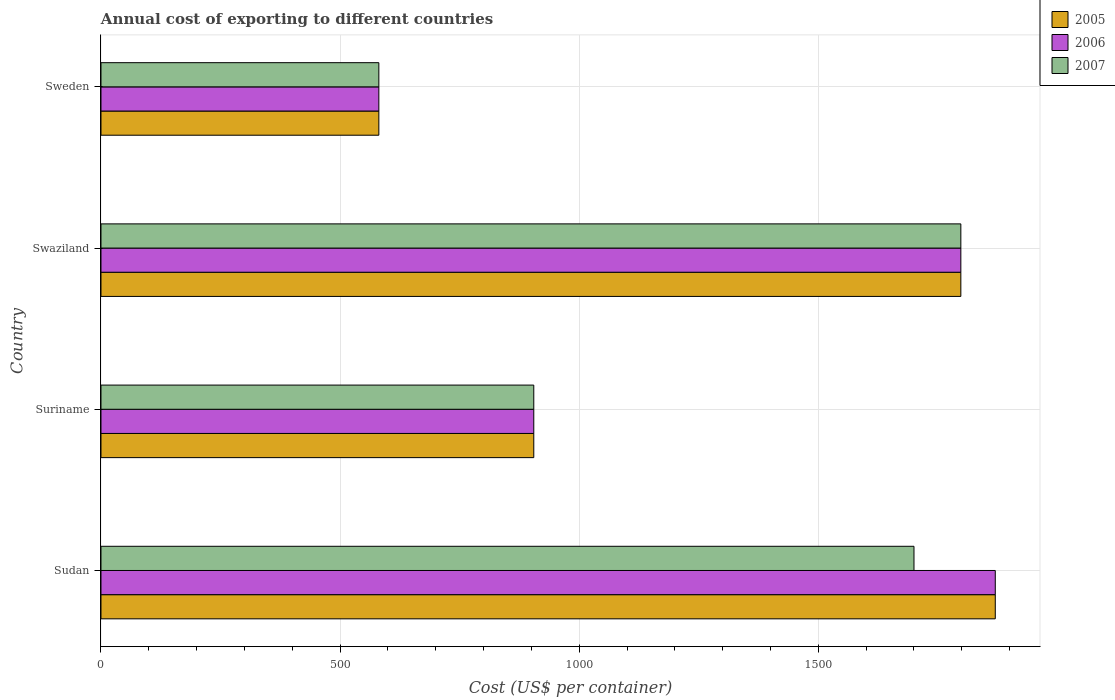How many different coloured bars are there?
Your answer should be very brief. 3. How many groups of bars are there?
Keep it short and to the point. 4. Are the number of bars per tick equal to the number of legend labels?
Give a very brief answer. Yes. How many bars are there on the 2nd tick from the top?
Make the answer very short. 3. How many bars are there on the 2nd tick from the bottom?
Make the answer very short. 3. What is the label of the 3rd group of bars from the top?
Provide a short and direct response. Suriname. What is the total annual cost of exporting in 2005 in Suriname?
Give a very brief answer. 905. Across all countries, what is the maximum total annual cost of exporting in 2007?
Provide a short and direct response. 1798. Across all countries, what is the minimum total annual cost of exporting in 2007?
Your response must be concise. 581. In which country was the total annual cost of exporting in 2007 maximum?
Provide a short and direct response. Swaziland. What is the total total annual cost of exporting in 2007 in the graph?
Provide a succinct answer. 4984. What is the difference between the total annual cost of exporting in 2007 in Sudan and that in Swaziland?
Offer a very short reply. -98. What is the difference between the total annual cost of exporting in 2007 in Suriname and the total annual cost of exporting in 2005 in Sweden?
Keep it short and to the point. 324. What is the average total annual cost of exporting in 2007 per country?
Provide a succinct answer. 1246. What is the difference between the total annual cost of exporting in 2005 and total annual cost of exporting in 2006 in Sudan?
Your answer should be very brief. 0. What is the ratio of the total annual cost of exporting in 2005 in Sudan to that in Suriname?
Give a very brief answer. 2.07. What is the difference between the highest and the lowest total annual cost of exporting in 2007?
Offer a very short reply. 1217. Is the sum of the total annual cost of exporting in 2006 in Suriname and Sweden greater than the maximum total annual cost of exporting in 2007 across all countries?
Ensure brevity in your answer.  No. What does the 2nd bar from the top in Sweden represents?
Provide a short and direct response. 2006. What does the 2nd bar from the bottom in Sudan represents?
Offer a very short reply. 2006. Is it the case that in every country, the sum of the total annual cost of exporting in 2006 and total annual cost of exporting in 2007 is greater than the total annual cost of exporting in 2005?
Your response must be concise. Yes. How many bars are there?
Your answer should be very brief. 12. What is the difference between two consecutive major ticks on the X-axis?
Keep it short and to the point. 500. Are the values on the major ticks of X-axis written in scientific E-notation?
Ensure brevity in your answer.  No. Does the graph contain any zero values?
Your answer should be compact. No. Does the graph contain grids?
Your answer should be compact. Yes. What is the title of the graph?
Provide a succinct answer. Annual cost of exporting to different countries. Does "1996" appear as one of the legend labels in the graph?
Provide a succinct answer. No. What is the label or title of the X-axis?
Your answer should be very brief. Cost (US$ per container). What is the Cost (US$ per container) of 2005 in Sudan?
Your response must be concise. 1870. What is the Cost (US$ per container) in 2006 in Sudan?
Provide a short and direct response. 1870. What is the Cost (US$ per container) of 2007 in Sudan?
Give a very brief answer. 1700. What is the Cost (US$ per container) in 2005 in Suriname?
Your answer should be compact. 905. What is the Cost (US$ per container) of 2006 in Suriname?
Keep it short and to the point. 905. What is the Cost (US$ per container) in 2007 in Suriname?
Your answer should be very brief. 905. What is the Cost (US$ per container) in 2005 in Swaziland?
Provide a succinct answer. 1798. What is the Cost (US$ per container) in 2006 in Swaziland?
Ensure brevity in your answer.  1798. What is the Cost (US$ per container) in 2007 in Swaziland?
Offer a very short reply. 1798. What is the Cost (US$ per container) of 2005 in Sweden?
Your response must be concise. 581. What is the Cost (US$ per container) in 2006 in Sweden?
Your response must be concise. 581. What is the Cost (US$ per container) of 2007 in Sweden?
Make the answer very short. 581. Across all countries, what is the maximum Cost (US$ per container) in 2005?
Your answer should be very brief. 1870. Across all countries, what is the maximum Cost (US$ per container) in 2006?
Provide a short and direct response. 1870. Across all countries, what is the maximum Cost (US$ per container) of 2007?
Offer a very short reply. 1798. Across all countries, what is the minimum Cost (US$ per container) in 2005?
Your answer should be very brief. 581. Across all countries, what is the minimum Cost (US$ per container) of 2006?
Your response must be concise. 581. Across all countries, what is the minimum Cost (US$ per container) in 2007?
Give a very brief answer. 581. What is the total Cost (US$ per container) in 2005 in the graph?
Your response must be concise. 5154. What is the total Cost (US$ per container) of 2006 in the graph?
Give a very brief answer. 5154. What is the total Cost (US$ per container) in 2007 in the graph?
Give a very brief answer. 4984. What is the difference between the Cost (US$ per container) of 2005 in Sudan and that in Suriname?
Give a very brief answer. 965. What is the difference between the Cost (US$ per container) in 2006 in Sudan and that in Suriname?
Your response must be concise. 965. What is the difference between the Cost (US$ per container) in 2007 in Sudan and that in Suriname?
Offer a terse response. 795. What is the difference between the Cost (US$ per container) in 2005 in Sudan and that in Swaziland?
Make the answer very short. 72. What is the difference between the Cost (US$ per container) in 2006 in Sudan and that in Swaziland?
Keep it short and to the point. 72. What is the difference between the Cost (US$ per container) in 2007 in Sudan and that in Swaziland?
Your answer should be very brief. -98. What is the difference between the Cost (US$ per container) of 2005 in Sudan and that in Sweden?
Give a very brief answer. 1289. What is the difference between the Cost (US$ per container) of 2006 in Sudan and that in Sweden?
Your answer should be very brief. 1289. What is the difference between the Cost (US$ per container) in 2007 in Sudan and that in Sweden?
Provide a short and direct response. 1119. What is the difference between the Cost (US$ per container) in 2005 in Suriname and that in Swaziland?
Make the answer very short. -893. What is the difference between the Cost (US$ per container) in 2006 in Suriname and that in Swaziland?
Keep it short and to the point. -893. What is the difference between the Cost (US$ per container) of 2007 in Suriname and that in Swaziland?
Offer a terse response. -893. What is the difference between the Cost (US$ per container) in 2005 in Suriname and that in Sweden?
Offer a very short reply. 324. What is the difference between the Cost (US$ per container) of 2006 in Suriname and that in Sweden?
Your response must be concise. 324. What is the difference between the Cost (US$ per container) in 2007 in Suriname and that in Sweden?
Provide a short and direct response. 324. What is the difference between the Cost (US$ per container) in 2005 in Swaziland and that in Sweden?
Your answer should be very brief. 1217. What is the difference between the Cost (US$ per container) of 2006 in Swaziland and that in Sweden?
Keep it short and to the point. 1217. What is the difference between the Cost (US$ per container) of 2007 in Swaziland and that in Sweden?
Keep it short and to the point. 1217. What is the difference between the Cost (US$ per container) of 2005 in Sudan and the Cost (US$ per container) of 2006 in Suriname?
Ensure brevity in your answer.  965. What is the difference between the Cost (US$ per container) of 2005 in Sudan and the Cost (US$ per container) of 2007 in Suriname?
Your response must be concise. 965. What is the difference between the Cost (US$ per container) in 2006 in Sudan and the Cost (US$ per container) in 2007 in Suriname?
Offer a terse response. 965. What is the difference between the Cost (US$ per container) of 2005 in Sudan and the Cost (US$ per container) of 2007 in Swaziland?
Keep it short and to the point. 72. What is the difference between the Cost (US$ per container) of 2005 in Sudan and the Cost (US$ per container) of 2006 in Sweden?
Provide a short and direct response. 1289. What is the difference between the Cost (US$ per container) in 2005 in Sudan and the Cost (US$ per container) in 2007 in Sweden?
Keep it short and to the point. 1289. What is the difference between the Cost (US$ per container) of 2006 in Sudan and the Cost (US$ per container) of 2007 in Sweden?
Make the answer very short. 1289. What is the difference between the Cost (US$ per container) of 2005 in Suriname and the Cost (US$ per container) of 2006 in Swaziland?
Make the answer very short. -893. What is the difference between the Cost (US$ per container) of 2005 in Suriname and the Cost (US$ per container) of 2007 in Swaziland?
Offer a very short reply. -893. What is the difference between the Cost (US$ per container) in 2006 in Suriname and the Cost (US$ per container) in 2007 in Swaziland?
Your response must be concise. -893. What is the difference between the Cost (US$ per container) in 2005 in Suriname and the Cost (US$ per container) in 2006 in Sweden?
Your answer should be very brief. 324. What is the difference between the Cost (US$ per container) in 2005 in Suriname and the Cost (US$ per container) in 2007 in Sweden?
Offer a terse response. 324. What is the difference between the Cost (US$ per container) of 2006 in Suriname and the Cost (US$ per container) of 2007 in Sweden?
Provide a short and direct response. 324. What is the difference between the Cost (US$ per container) in 2005 in Swaziland and the Cost (US$ per container) in 2006 in Sweden?
Your answer should be compact. 1217. What is the difference between the Cost (US$ per container) of 2005 in Swaziland and the Cost (US$ per container) of 2007 in Sweden?
Your answer should be compact. 1217. What is the difference between the Cost (US$ per container) of 2006 in Swaziland and the Cost (US$ per container) of 2007 in Sweden?
Your response must be concise. 1217. What is the average Cost (US$ per container) in 2005 per country?
Provide a short and direct response. 1288.5. What is the average Cost (US$ per container) in 2006 per country?
Your answer should be compact. 1288.5. What is the average Cost (US$ per container) of 2007 per country?
Offer a terse response. 1246. What is the difference between the Cost (US$ per container) of 2005 and Cost (US$ per container) of 2007 in Sudan?
Provide a short and direct response. 170. What is the difference between the Cost (US$ per container) in 2006 and Cost (US$ per container) in 2007 in Sudan?
Ensure brevity in your answer.  170. What is the difference between the Cost (US$ per container) in 2005 and Cost (US$ per container) in 2006 in Suriname?
Provide a succinct answer. 0. What is the difference between the Cost (US$ per container) in 2005 and Cost (US$ per container) in 2006 in Sweden?
Provide a succinct answer. 0. What is the ratio of the Cost (US$ per container) in 2005 in Sudan to that in Suriname?
Provide a succinct answer. 2.07. What is the ratio of the Cost (US$ per container) of 2006 in Sudan to that in Suriname?
Ensure brevity in your answer.  2.07. What is the ratio of the Cost (US$ per container) in 2007 in Sudan to that in Suriname?
Your response must be concise. 1.88. What is the ratio of the Cost (US$ per container) of 2005 in Sudan to that in Swaziland?
Provide a short and direct response. 1.04. What is the ratio of the Cost (US$ per container) in 2006 in Sudan to that in Swaziland?
Make the answer very short. 1.04. What is the ratio of the Cost (US$ per container) of 2007 in Sudan to that in Swaziland?
Make the answer very short. 0.95. What is the ratio of the Cost (US$ per container) in 2005 in Sudan to that in Sweden?
Provide a succinct answer. 3.22. What is the ratio of the Cost (US$ per container) in 2006 in Sudan to that in Sweden?
Ensure brevity in your answer.  3.22. What is the ratio of the Cost (US$ per container) in 2007 in Sudan to that in Sweden?
Your answer should be compact. 2.93. What is the ratio of the Cost (US$ per container) of 2005 in Suriname to that in Swaziland?
Provide a short and direct response. 0.5. What is the ratio of the Cost (US$ per container) in 2006 in Suriname to that in Swaziland?
Offer a terse response. 0.5. What is the ratio of the Cost (US$ per container) in 2007 in Suriname to that in Swaziland?
Your answer should be very brief. 0.5. What is the ratio of the Cost (US$ per container) in 2005 in Suriname to that in Sweden?
Make the answer very short. 1.56. What is the ratio of the Cost (US$ per container) of 2006 in Suriname to that in Sweden?
Offer a very short reply. 1.56. What is the ratio of the Cost (US$ per container) of 2007 in Suriname to that in Sweden?
Your answer should be very brief. 1.56. What is the ratio of the Cost (US$ per container) in 2005 in Swaziland to that in Sweden?
Provide a short and direct response. 3.09. What is the ratio of the Cost (US$ per container) of 2006 in Swaziland to that in Sweden?
Your answer should be very brief. 3.09. What is the ratio of the Cost (US$ per container) in 2007 in Swaziland to that in Sweden?
Offer a very short reply. 3.09. What is the difference between the highest and the second highest Cost (US$ per container) of 2005?
Keep it short and to the point. 72. What is the difference between the highest and the second highest Cost (US$ per container) in 2007?
Your answer should be compact. 98. What is the difference between the highest and the lowest Cost (US$ per container) in 2005?
Make the answer very short. 1289. What is the difference between the highest and the lowest Cost (US$ per container) in 2006?
Offer a terse response. 1289. What is the difference between the highest and the lowest Cost (US$ per container) in 2007?
Your answer should be very brief. 1217. 